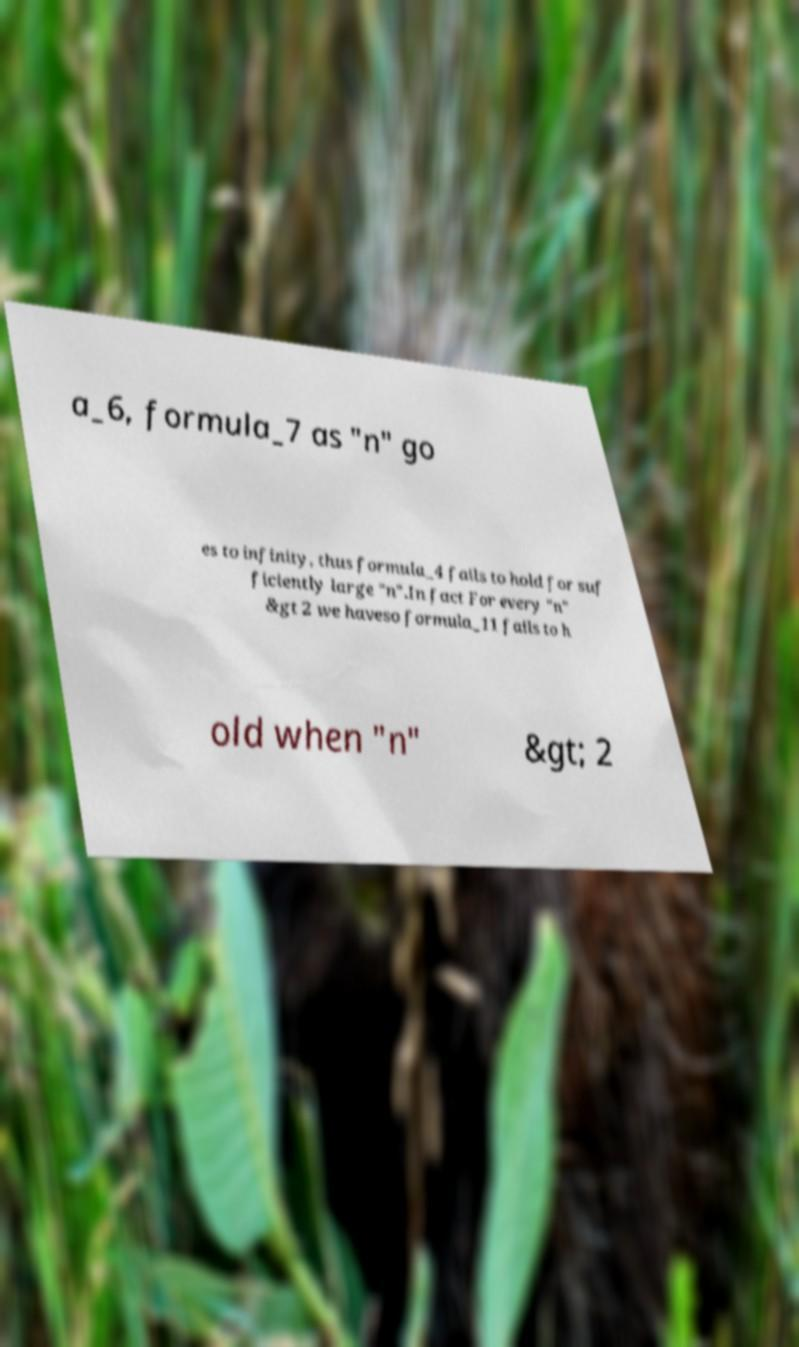For documentation purposes, I need the text within this image transcribed. Could you provide that? a_6, formula_7 as "n" go es to infinity, thus formula_4 fails to hold for suf ficiently large "n".In fact For every "n" &gt 2 we haveso formula_11 fails to h old when "n" &gt; 2 